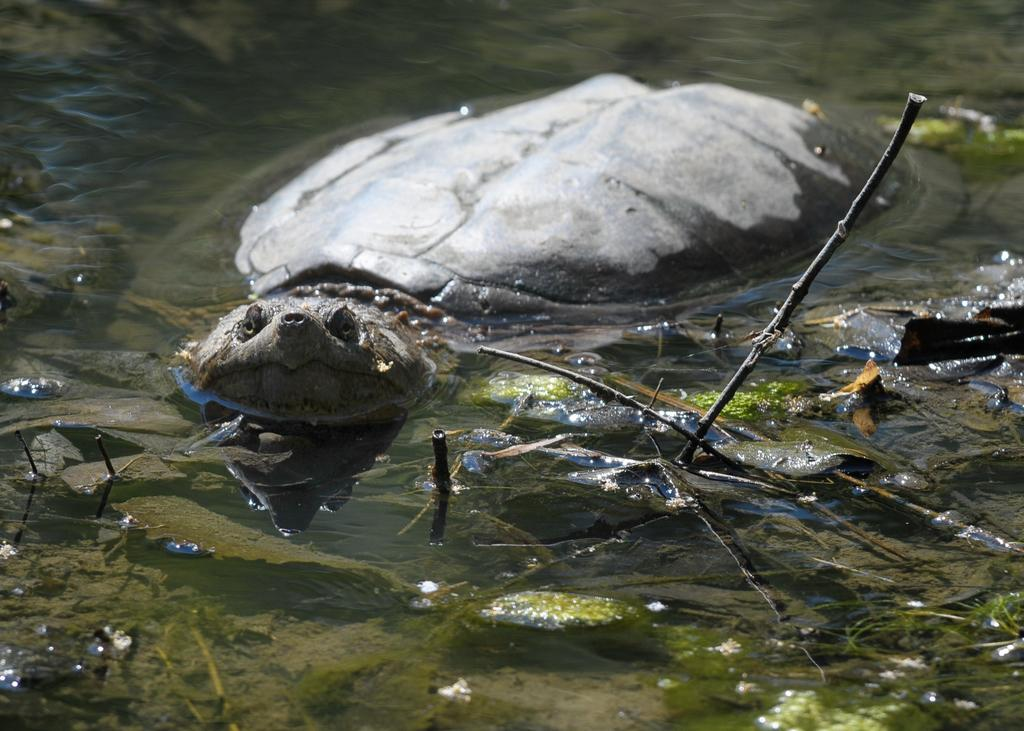What animal is present in the image? There is a tortoise in the image. What is the tortoise doing in the image? The tortoise is swimming in the water. What letter can be seen floating on the water near the tortoise? There is no letter visible in the image; it only features a tortoise swimming in the water. 